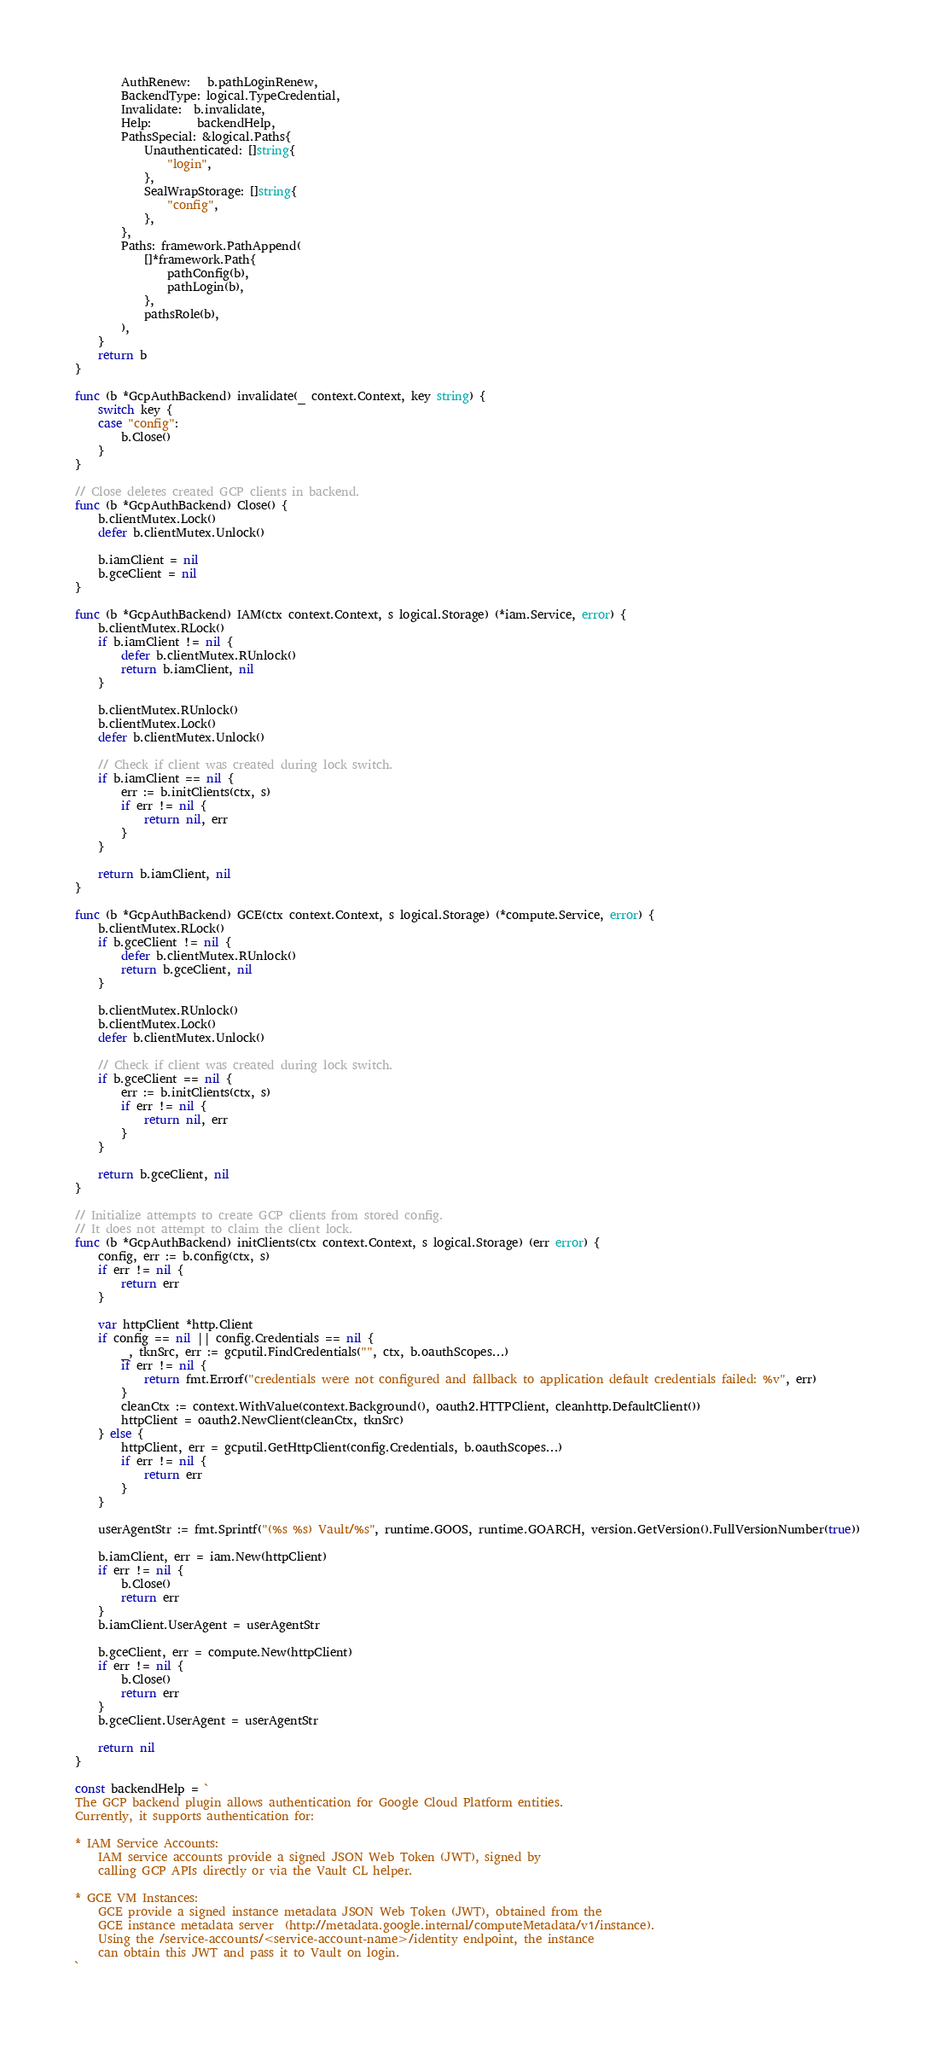Convert code to text. <code><loc_0><loc_0><loc_500><loc_500><_Go_>		AuthRenew:   b.pathLoginRenew,
		BackendType: logical.TypeCredential,
		Invalidate:  b.invalidate,
		Help:        backendHelp,
		PathsSpecial: &logical.Paths{
			Unauthenticated: []string{
				"login",
			},
			SealWrapStorage: []string{
				"config",
			},
		},
		Paths: framework.PathAppend(
			[]*framework.Path{
				pathConfig(b),
				pathLogin(b),
			},
			pathsRole(b),
		),
	}
	return b
}

func (b *GcpAuthBackend) invalidate(_ context.Context, key string) {
	switch key {
	case "config":
		b.Close()
	}
}

// Close deletes created GCP clients in backend.
func (b *GcpAuthBackend) Close() {
	b.clientMutex.Lock()
	defer b.clientMutex.Unlock()

	b.iamClient = nil
	b.gceClient = nil
}

func (b *GcpAuthBackend) IAM(ctx context.Context, s logical.Storage) (*iam.Service, error) {
	b.clientMutex.RLock()
	if b.iamClient != nil {
		defer b.clientMutex.RUnlock()
		return b.iamClient, nil
	}

	b.clientMutex.RUnlock()
	b.clientMutex.Lock()
	defer b.clientMutex.Unlock()

	// Check if client was created during lock switch.
	if b.iamClient == nil {
		err := b.initClients(ctx, s)
		if err != nil {
			return nil, err
		}
	}

	return b.iamClient, nil
}

func (b *GcpAuthBackend) GCE(ctx context.Context, s logical.Storage) (*compute.Service, error) {
	b.clientMutex.RLock()
	if b.gceClient != nil {
		defer b.clientMutex.RUnlock()
		return b.gceClient, nil
	}

	b.clientMutex.RUnlock()
	b.clientMutex.Lock()
	defer b.clientMutex.Unlock()

	// Check if client was created during lock switch.
	if b.gceClient == nil {
		err := b.initClients(ctx, s)
		if err != nil {
			return nil, err
		}
	}

	return b.gceClient, nil
}

// Initialize attempts to create GCP clients from stored config.
// It does not attempt to claim the client lock.
func (b *GcpAuthBackend) initClients(ctx context.Context, s logical.Storage) (err error) {
	config, err := b.config(ctx, s)
	if err != nil {
		return err
	}

	var httpClient *http.Client
	if config == nil || config.Credentials == nil {
		_, tknSrc, err := gcputil.FindCredentials("", ctx, b.oauthScopes...)
		if err != nil {
			return fmt.Errorf("credentials were not configured and fallback to application default credentials failed: %v", err)
		}
		cleanCtx := context.WithValue(context.Background(), oauth2.HTTPClient, cleanhttp.DefaultClient())
		httpClient = oauth2.NewClient(cleanCtx, tknSrc)
	} else {
		httpClient, err = gcputil.GetHttpClient(config.Credentials, b.oauthScopes...)
		if err != nil {
			return err
		}
	}

	userAgentStr := fmt.Sprintf("(%s %s) Vault/%s", runtime.GOOS, runtime.GOARCH, version.GetVersion().FullVersionNumber(true))

	b.iamClient, err = iam.New(httpClient)
	if err != nil {
		b.Close()
		return err
	}
	b.iamClient.UserAgent = userAgentStr

	b.gceClient, err = compute.New(httpClient)
	if err != nil {
		b.Close()
		return err
	}
	b.gceClient.UserAgent = userAgentStr

	return nil
}

const backendHelp = `
The GCP backend plugin allows authentication for Google Cloud Platform entities.
Currently, it supports authentication for:

* IAM Service Accounts:
	IAM service accounts provide a signed JSON Web Token (JWT), signed by
	calling GCP APIs directly or via the Vault CL helper.

* GCE VM Instances:
	GCE provide a signed instance metadata JSON Web Token (JWT), obtained from the
	GCE instance metadata server  (http://metadata.google.internal/computeMetadata/v1/instance).
	Using the /service-accounts/<service-account-name>/identity	endpoint, the instance
	can obtain this JWT and pass it to Vault on login.
`
</code> 